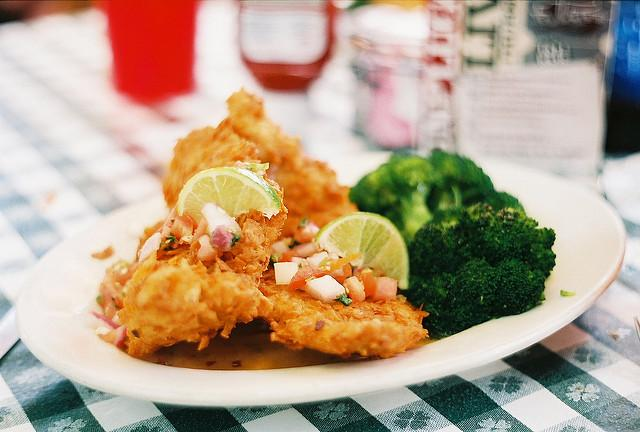What citrus fruit is atop the fried food?

Choices:
A) lime
B) orange
C) grapefruit
D) lemon lime 